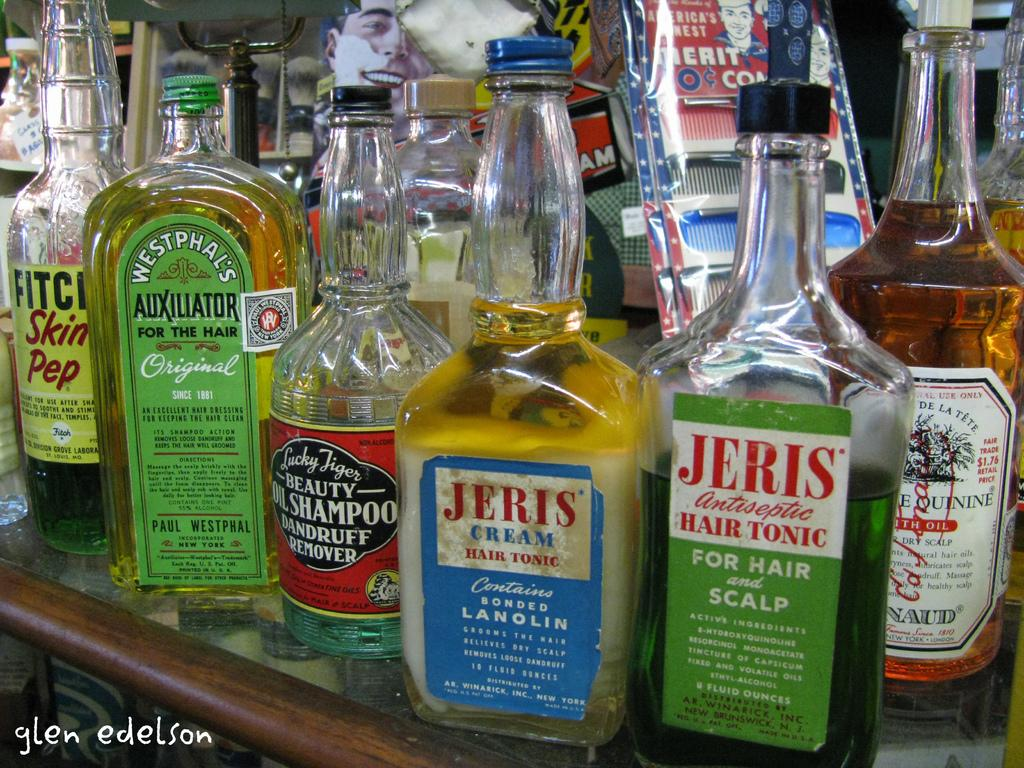<image>
Describe the image concisely. Bottles of Jeris hair products are lined up with other glass bottles on a shelf. 